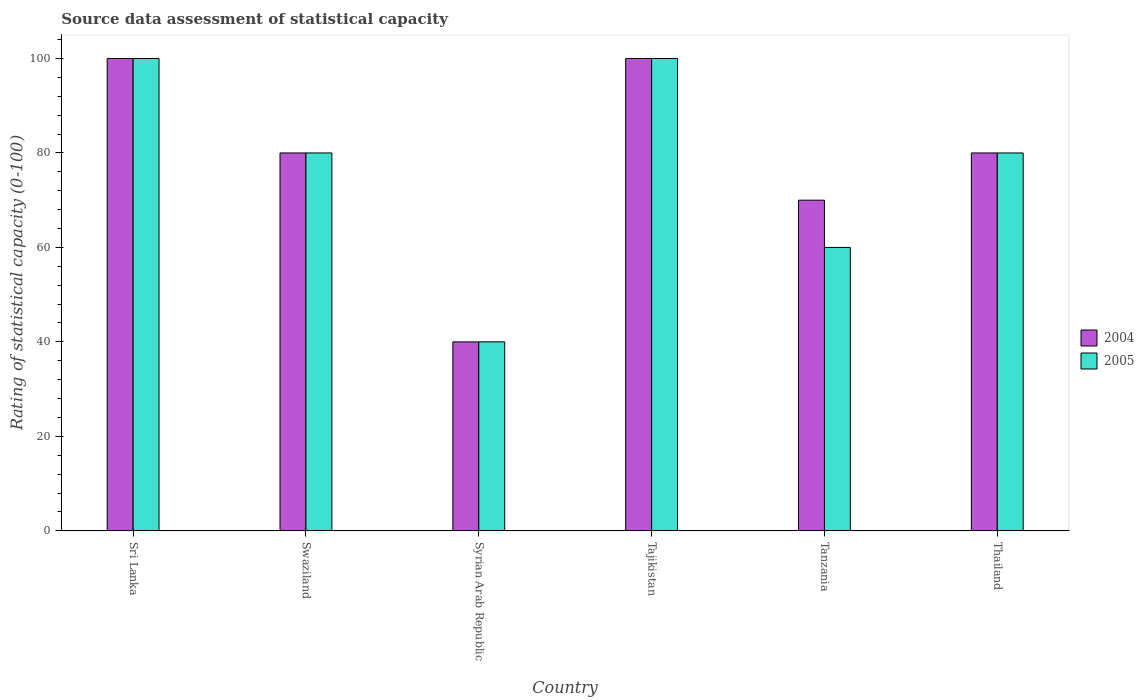How many different coloured bars are there?
Offer a very short reply. 2. How many bars are there on the 4th tick from the right?
Offer a very short reply. 2. What is the label of the 3rd group of bars from the left?
Offer a terse response. Syrian Arab Republic. In which country was the rating of statistical capacity in 2004 maximum?
Your response must be concise. Sri Lanka. In which country was the rating of statistical capacity in 2005 minimum?
Make the answer very short. Syrian Arab Republic. What is the total rating of statistical capacity in 2004 in the graph?
Your answer should be compact. 470. What is the difference between the rating of statistical capacity in 2004 in Syrian Arab Republic and the rating of statistical capacity in 2005 in Tanzania?
Provide a succinct answer. -20. What is the average rating of statistical capacity in 2005 per country?
Ensure brevity in your answer.  76.67. In how many countries, is the rating of statistical capacity in 2004 greater than 12?
Offer a terse response. 6. Is the rating of statistical capacity in 2004 in Sri Lanka less than that in Swaziland?
Your answer should be very brief. No. What is the difference between the highest and the second highest rating of statistical capacity in 2005?
Keep it short and to the point. -20. What is the difference between the highest and the lowest rating of statistical capacity in 2004?
Your answer should be compact. 60. What does the 1st bar from the left in Sri Lanka represents?
Give a very brief answer. 2004. How many bars are there?
Make the answer very short. 12. Does the graph contain grids?
Give a very brief answer. No. How are the legend labels stacked?
Provide a succinct answer. Vertical. What is the title of the graph?
Keep it short and to the point. Source data assessment of statistical capacity. Does "2009" appear as one of the legend labels in the graph?
Give a very brief answer. No. What is the label or title of the Y-axis?
Ensure brevity in your answer.  Rating of statistical capacity (0-100). What is the Rating of statistical capacity (0-100) of 2004 in Swaziland?
Provide a short and direct response. 80. What is the Rating of statistical capacity (0-100) of 2004 in Syrian Arab Republic?
Give a very brief answer. 40. What is the Rating of statistical capacity (0-100) in 2005 in Syrian Arab Republic?
Give a very brief answer. 40. What is the Rating of statistical capacity (0-100) in 2004 in Tajikistan?
Ensure brevity in your answer.  100. What is the Rating of statistical capacity (0-100) of 2004 in Tanzania?
Keep it short and to the point. 70. What is the Rating of statistical capacity (0-100) of 2005 in Tanzania?
Make the answer very short. 60. What is the Rating of statistical capacity (0-100) of 2005 in Thailand?
Your answer should be very brief. 80. Across all countries, what is the maximum Rating of statistical capacity (0-100) of 2004?
Offer a very short reply. 100. Across all countries, what is the minimum Rating of statistical capacity (0-100) of 2004?
Make the answer very short. 40. Across all countries, what is the minimum Rating of statistical capacity (0-100) of 2005?
Ensure brevity in your answer.  40. What is the total Rating of statistical capacity (0-100) of 2004 in the graph?
Offer a terse response. 470. What is the total Rating of statistical capacity (0-100) of 2005 in the graph?
Your answer should be very brief. 460. What is the difference between the Rating of statistical capacity (0-100) of 2004 in Sri Lanka and that in Swaziland?
Your answer should be compact. 20. What is the difference between the Rating of statistical capacity (0-100) in 2004 in Sri Lanka and that in Syrian Arab Republic?
Your answer should be very brief. 60. What is the difference between the Rating of statistical capacity (0-100) of 2004 in Sri Lanka and that in Tajikistan?
Offer a terse response. 0. What is the difference between the Rating of statistical capacity (0-100) of 2005 in Sri Lanka and that in Tajikistan?
Your answer should be very brief. 0. What is the difference between the Rating of statistical capacity (0-100) of 2004 in Sri Lanka and that in Tanzania?
Ensure brevity in your answer.  30. What is the difference between the Rating of statistical capacity (0-100) of 2005 in Sri Lanka and that in Tanzania?
Provide a succinct answer. 40. What is the difference between the Rating of statistical capacity (0-100) in 2005 in Sri Lanka and that in Thailand?
Your answer should be very brief. 20. What is the difference between the Rating of statistical capacity (0-100) of 2004 in Swaziland and that in Syrian Arab Republic?
Your answer should be very brief. 40. What is the difference between the Rating of statistical capacity (0-100) in 2005 in Swaziland and that in Syrian Arab Republic?
Your answer should be very brief. 40. What is the difference between the Rating of statistical capacity (0-100) of 2004 in Swaziland and that in Tajikistan?
Keep it short and to the point. -20. What is the difference between the Rating of statistical capacity (0-100) in 2004 in Swaziland and that in Thailand?
Your answer should be compact. 0. What is the difference between the Rating of statistical capacity (0-100) in 2005 in Swaziland and that in Thailand?
Offer a terse response. 0. What is the difference between the Rating of statistical capacity (0-100) in 2004 in Syrian Arab Republic and that in Tajikistan?
Your answer should be very brief. -60. What is the difference between the Rating of statistical capacity (0-100) in 2005 in Syrian Arab Republic and that in Tajikistan?
Offer a terse response. -60. What is the difference between the Rating of statistical capacity (0-100) of 2005 in Syrian Arab Republic and that in Tanzania?
Give a very brief answer. -20. What is the difference between the Rating of statistical capacity (0-100) of 2005 in Syrian Arab Republic and that in Thailand?
Your answer should be very brief. -40. What is the difference between the Rating of statistical capacity (0-100) of 2005 in Tajikistan and that in Tanzania?
Your answer should be very brief. 40. What is the difference between the Rating of statistical capacity (0-100) of 2004 in Tajikistan and that in Thailand?
Your answer should be very brief. 20. What is the difference between the Rating of statistical capacity (0-100) in 2005 in Tanzania and that in Thailand?
Give a very brief answer. -20. What is the difference between the Rating of statistical capacity (0-100) in 2004 in Sri Lanka and the Rating of statistical capacity (0-100) in 2005 in Swaziland?
Your response must be concise. 20. What is the difference between the Rating of statistical capacity (0-100) of 2004 in Sri Lanka and the Rating of statistical capacity (0-100) of 2005 in Tajikistan?
Give a very brief answer. 0. What is the difference between the Rating of statistical capacity (0-100) in 2004 in Swaziland and the Rating of statistical capacity (0-100) in 2005 in Tajikistan?
Offer a terse response. -20. What is the difference between the Rating of statistical capacity (0-100) of 2004 in Swaziland and the Rating of statistical capacity (0-100) of 2005 in Tanzania?
Offer a very short reply. 20. What is the difference between the Rating of statistical capacity (0-100) of 2004 in Syrian Arab Republic and the Rating of statistical capacity (0-100) of 2005 in Tajikistan?
Offer a terse response. -60. What is the difference between the Rating of statistical capacity (0-100) of 2004 in Tajikistan and the Rating of statistical capacity (0-100) of 2005 in Tanzania?
Your answer should be very brief. 40. What is the difference between the Rating of statistical capacity (0-100) in 2004 in Tajikistan and the Rating of statistical capacity (0-100) in 2005 in Thailand?
Provide a succinct answer. 20. What is the average Rating of statistical capacity (0-100) in 2004 per country?
Provide a succinct answer. 78.33. What is the average Rating of statistical capacity (0-100) of 2005 per country?
Ensure brevity in your answer.  76.67. What is the difference between the Rating of statistical capacity (0-100) of 2004 and Rating of statistical capacity (0-100) of 2005 in Syrian Arab Republic?
Your answer should be very brief. 0. What is the difference between the Rating of statistical capacity (0-100) in 2004 and Rating of statistical capacity (0-100) in 2005 in Tajikistan?
Offer a very short reply. 0. What is the difference between the Rating of statistical capacity (0-100) in 2004 and Rating of statistical capacity (0-100) in 2005 in Thailand?
Offer a terse response. 0. What is the ratio of the Rating of statistical capacity (0-100) in 2004 in Sri Lanka to that in Swaziland?
Your response must be concise. 1.25. What is the ratio of the Rating of statistical capacity (0-100) of 2005 in Sri Lanka to that in Swaziland?
Provide a short and direct response. 1.25. What is the ratio of the Rating of statistical capacity (0-100) in 2005 in Sri Lanka to that in Syrian Arab Republic?
Offer a very short reply. 2.5. What is the ratio of the Rating of statistical capacity (0-100) in 2005 in Sri Lanka to that in Tajikistan?
Your response must be concise. 1. What is the ratio of the Rating of statistical capacity (0-100) of 2004 in Sri Lanka to that in Tanzania?
Provide a succinct answer. 1.43. What is the ratio of the Rating of statistical capacity (0-100) in 2005 in Sri Lanka to that in Tanzania?
Provide a short and direct response. 1.67. What is the ratio of the Rating of statistical capacity (0-100) of 2004 in Sri Lanka to that in Thailand?
Keep it short and to the point. 1.25. What is the ratio of the Rating of statistical capacity (0-100) of 2005 in Sri Lanka to that in Thailand?
Your answer should be compact. 1.25. What is the ratio of the Rating of statistical capacity (0-100) in 2004 in Swaziland to that in Syrian Arab Republic?
Your answer should be compact. 2. What is the ratio of the Rating of statistical capacity (0-100) in 2005 in Swaziland to that in Syrian Arab Republic?
Offer a terse response. 2. What is the ratio of the Rating of statistical capacity (0-100) of 2004 in Swaziland to that in Thailand?
Keep it short and to the point. 1. What is the ratio of the Rating of statistical capacity (0-100) in 2005 in Swaziland to that in Thailand?
Provide a short and direct response. 1. What is the ratio of the Rating of statistical capacity (0-100) of 2005 in Syrian Arab Republic to that in Tajikistan?
Your answer should be compact. 0.4. What is the ratio of the Rating of statistical capacity (0-100) in 2004 in Syrian Arab Republic to that in Tanzania?
Your answer should be compact. 0.57. What is the ratio of the Rating of statistical capacity (0-100) of 2005 in Syrian Arab Republic to that in Thailand?
Provide a short and direct response. 0.5. What is the ratio of the Rating of statistical capacity (0-100) of 2004 in Tajikistan to that in Tanzania?
Offer a terse response. 1.43. What is the ratio of the Rating of statistical capacity (0-100) of 2004 in Tajikistan to that in Thailand?
Your response must be concise. 1.25. What is the ratio of the Rating of statistical capacity (0-100) in 2005 in Tanzania to that in Thailand?
Give a very brief answer. 0.75. What is the difference between the highest and the lowest Rating of statistical capacity (0-100) in 2004?
Provide a succinct answer. 60. 